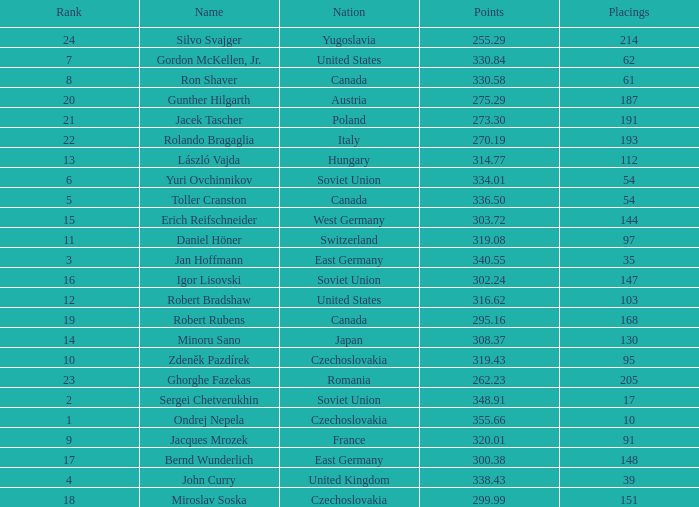Which Nation has Points of 300.38? East Germany. 